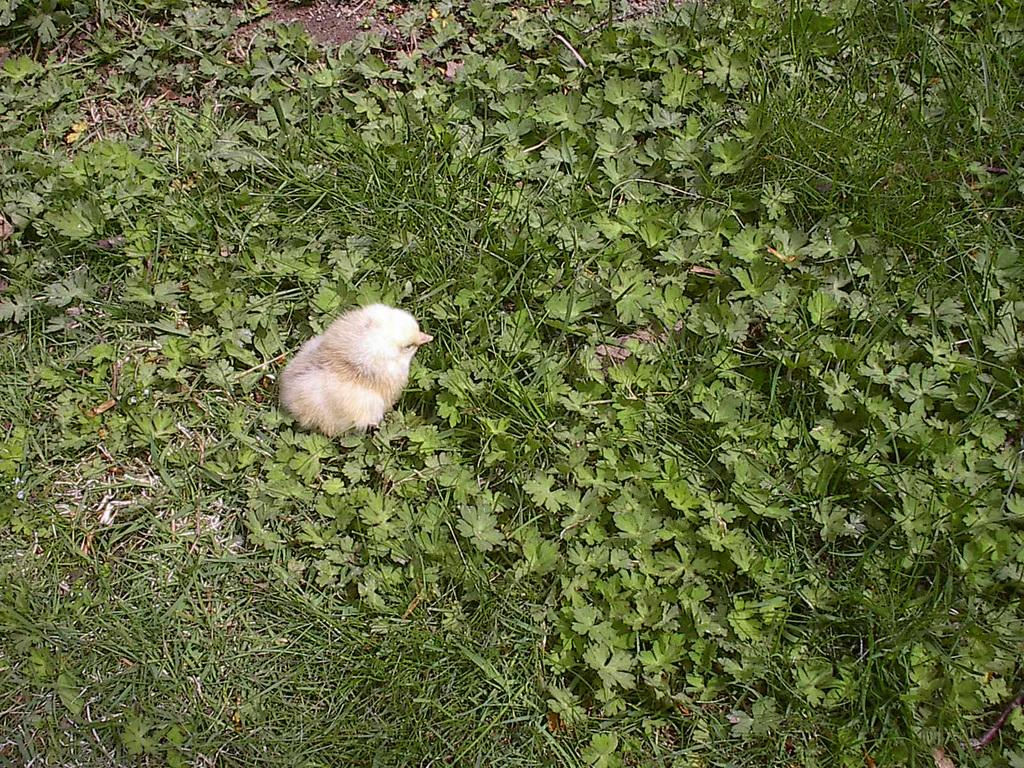What type of animal is in the image? There is a chick in the image. What is the ground covered with in the image? The ground in the image is covered in greenery. What type of harbor can be seen in the image? There is no harbor present in the image; it features a chick and greenery. What color is the chick's skin in the image? Chicks do not have skin visible in the same way as humans or mammals; they have feathers covering their bodies. 